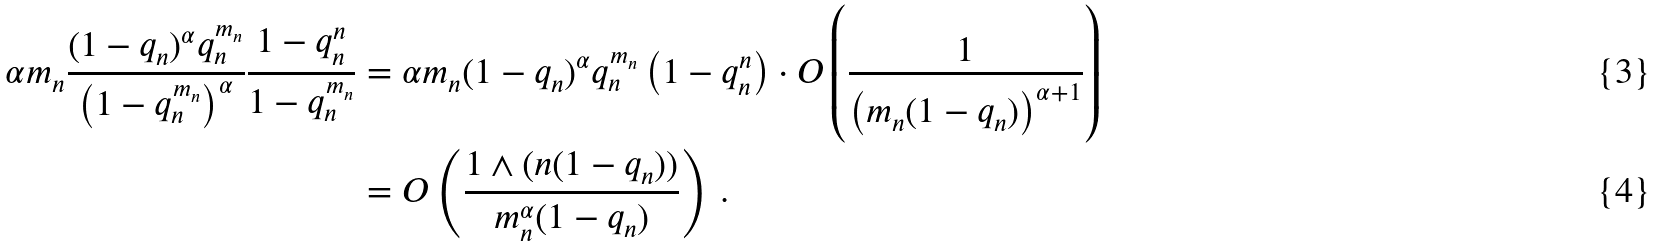Convert formula to latex. <formula><loc_0><loc_0><loc_500><loc_500>\alpha m _ { n } \frac { ( 1 - q _ { n } ) ^ { \alpha } q _ { n } ^ { m _ { n } } } { \left ( 1 - q _ { n } ^ { m _ { n } } \right ) ^ { \alpha } } \frac { 1 - q _ { n } ^ { n } } { 1 - q _ { n } ^ { m _ { n } } } & = \alpha m _ { n } ( 1 - q _ { n } ) ^ { \alpha } q _ { n } ^ { m _ { n } } \left ( 1 - q _ { n } ^ { n } \right ) \cdot O \left ( \frac { 1 } { \left ( m _ { n } ( 1 - q _ { n } ) \right ) ^ { \alpha + 1 } } \right ) \\ & = O \left ( \frac { 1 \wedge ( n ( 1 - q _ { n } ) ) } { m _ { n } ^ { \alpha } ( 1 - q _ { n } ) } \right ) \, .</formula> 